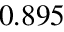<formula> <loc_0><loc_0><loc_500><loc_500>0 . 8 9 5</formula> 